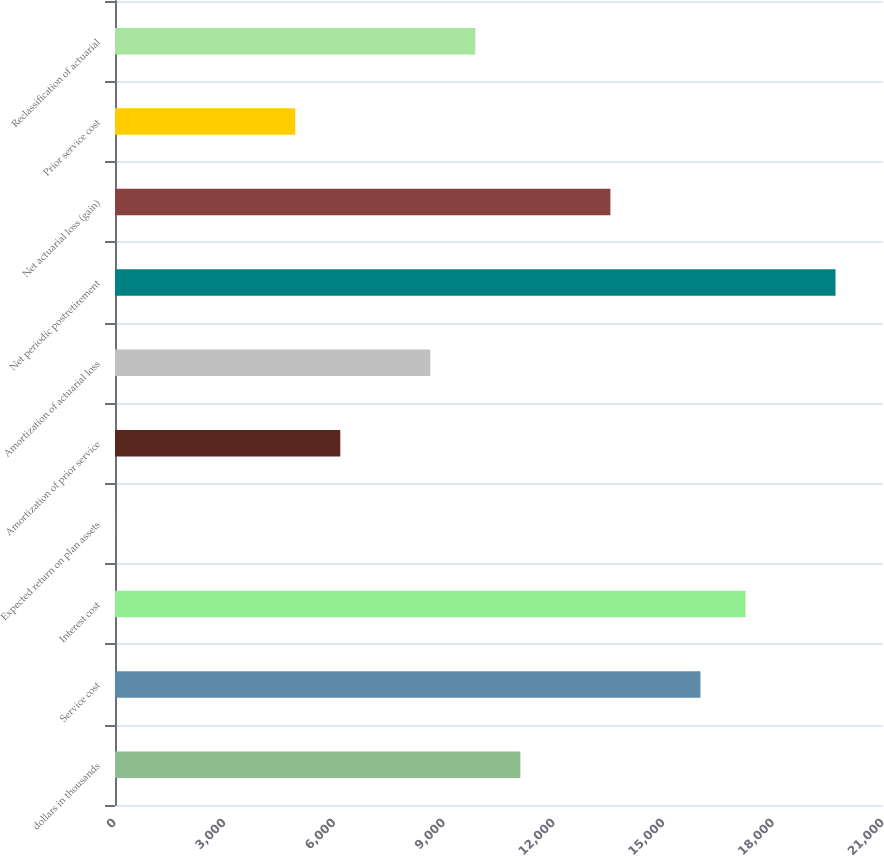Convert chart. <chart><loc_0><loc_0><loc_500><loc_500><bar_chart><fcel>dollars in thousands<fcel>Service cost<fcel>Interest cost<fcel>Expected return on plan assets<fcel>Amortization of prior service<fcel>Amortization of actuarial loss<fcel>Net periodic postretirement<fcel>Net actuarial loss (gain)<fcel>Prior service cost<fcel>Reclassification of actuarial<nl><fcel>11083.9<fcel>16008.3<fcel>17239.4<fcel>3.95<fcel>6159.47<fcel>8621.68<fcel>19701.6<fcel>13546.1<fcel>4928.36<fcel>9852.78<nl></chart> 